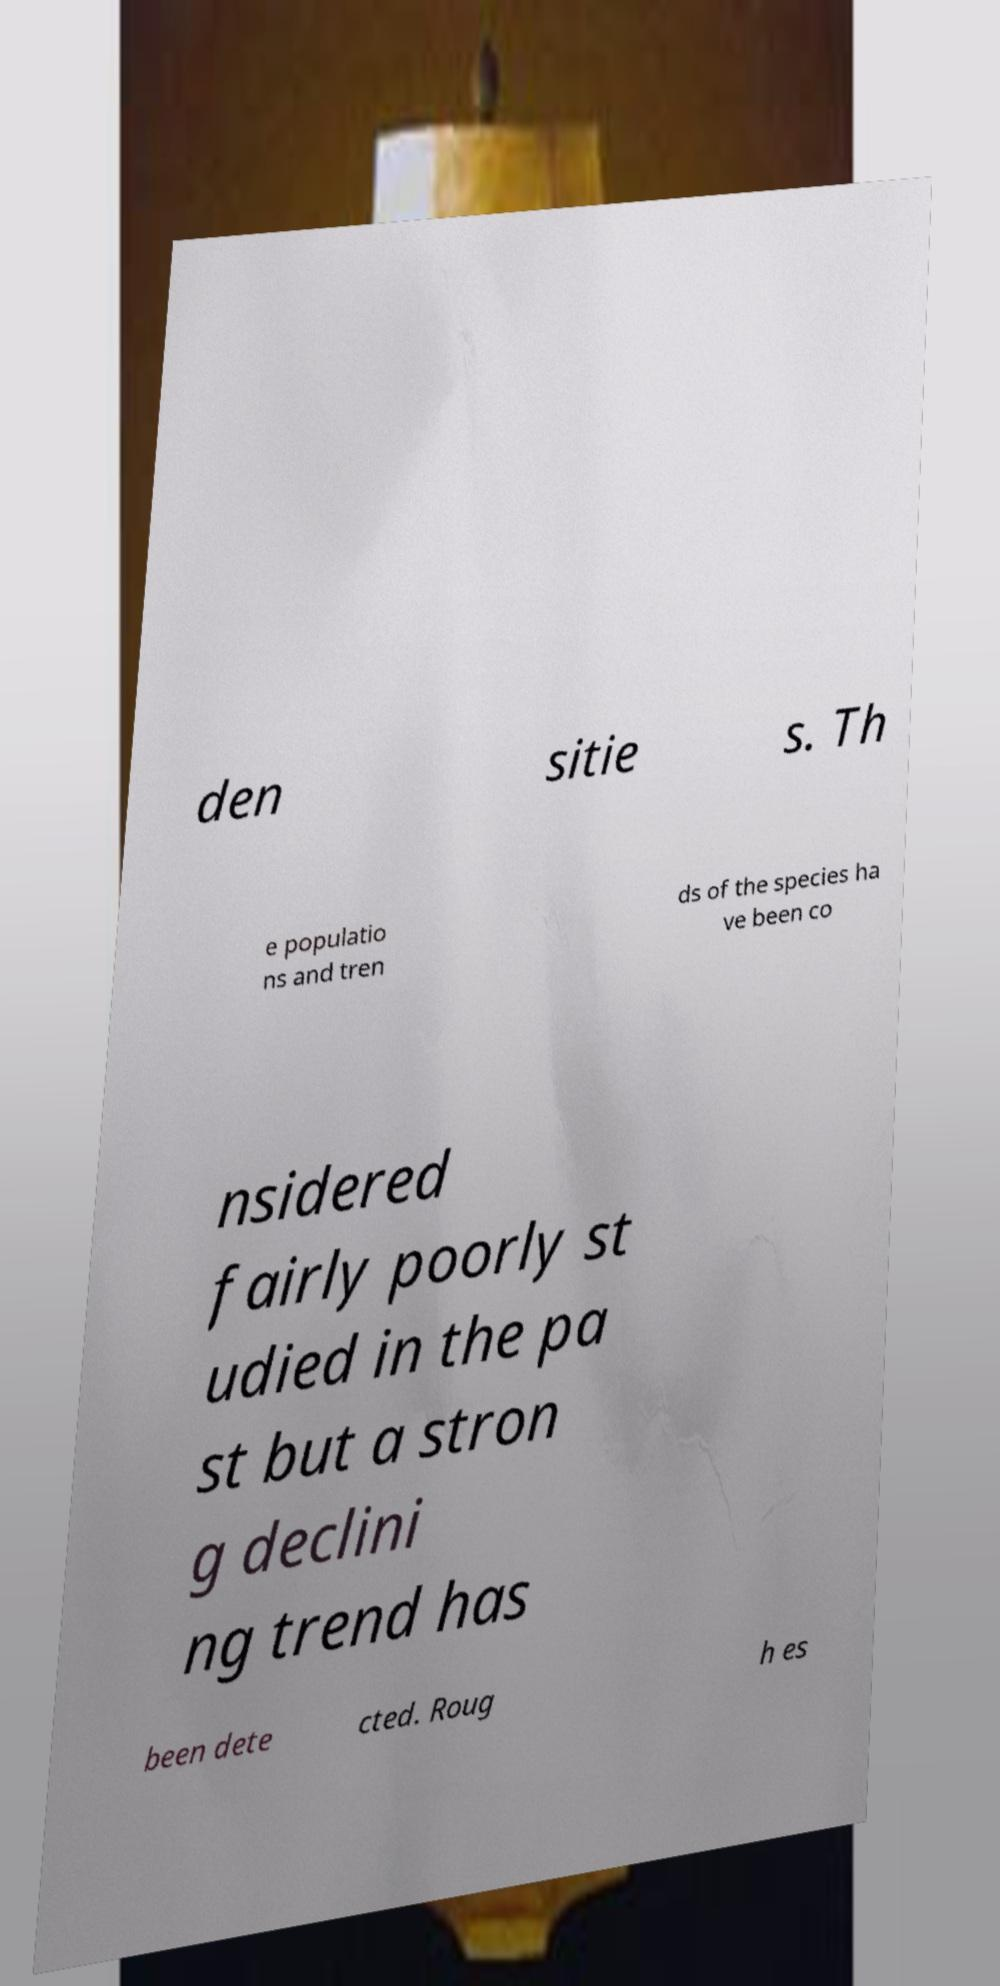What messages or text are displayed in this image? I need them in a readable, typed format. den sitie s. Th e populatio ns and tren ds of the species ha ve been co nsidered fairly poorly st udied in the pa st but a stron g declini ng trend has been dete cted. Roug h es 